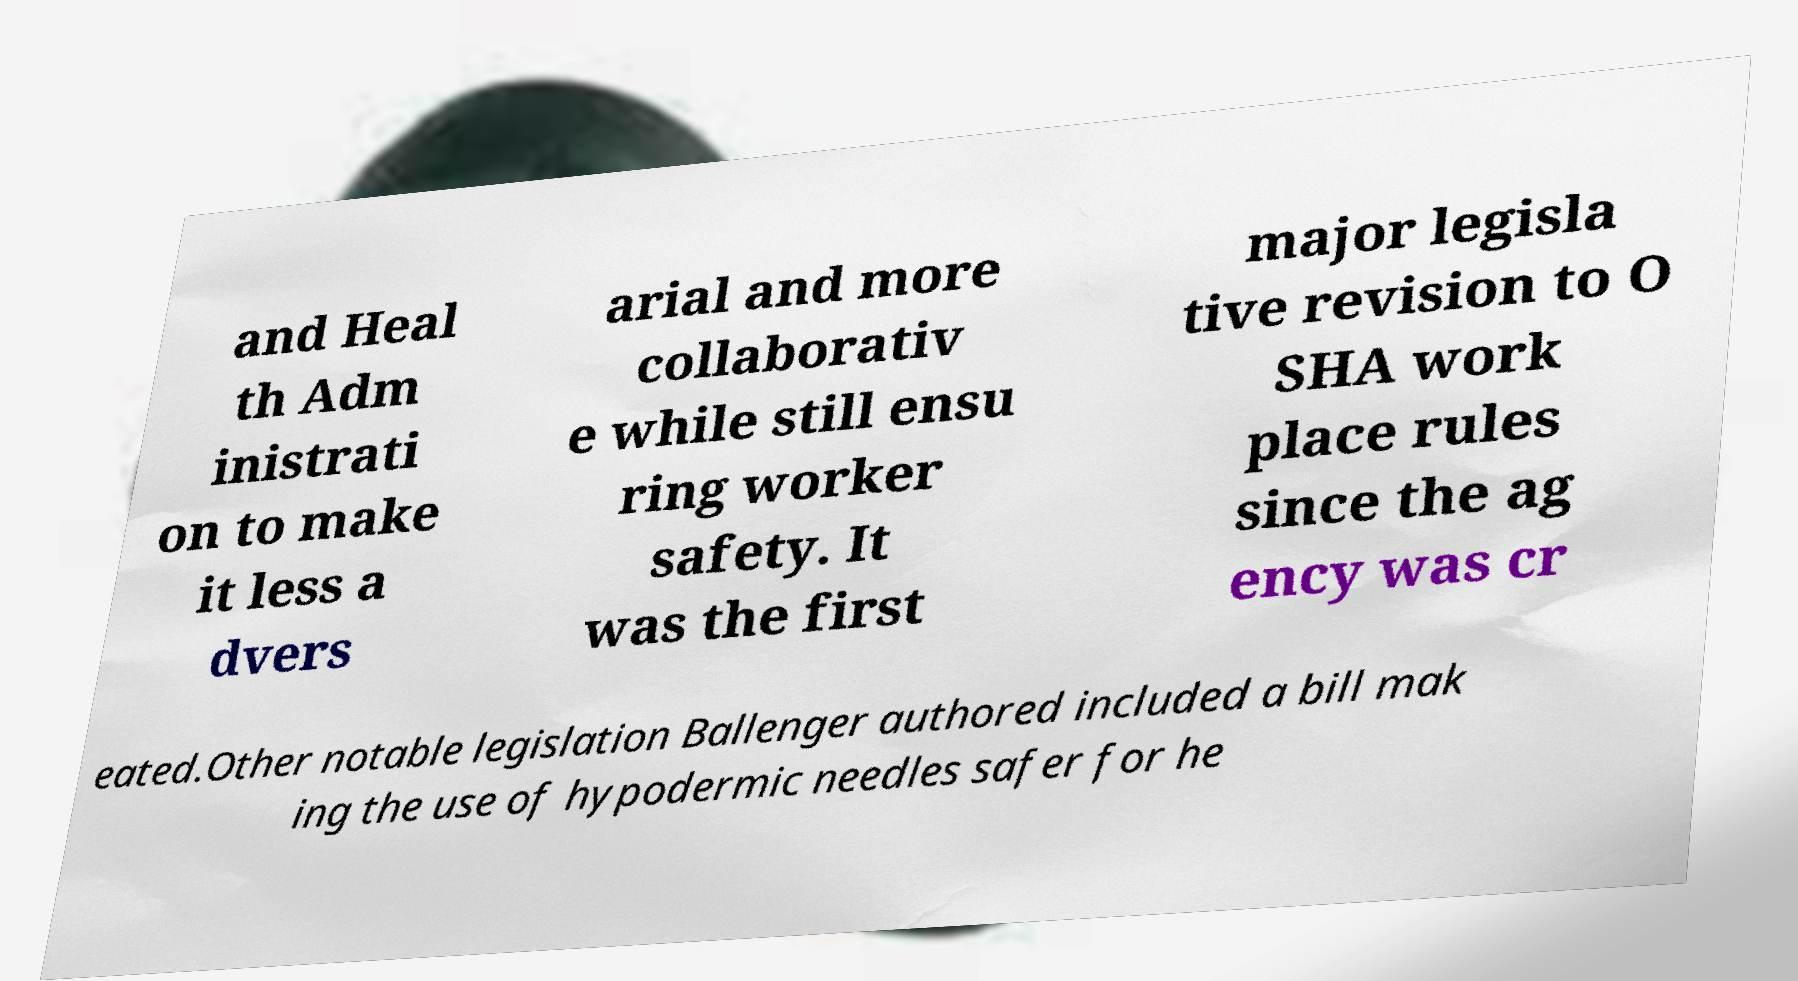Could you assist in decoding the text presented in this image and type it out clearly? and Heal th Adm inistrati on to make it less a dvers arial and more collaborativ e while still ensu ring worker safety. It was the first major legisla tive revision to O SHA work place rules since the ag ency was cr eated.Other notable legislation Ballenger authored included a bill mak ing the use of hypodermic needles safer for he 